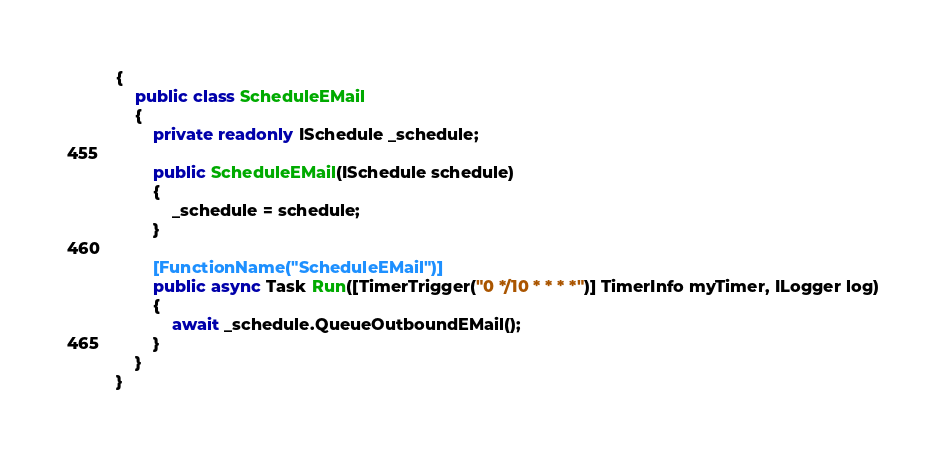<code> <loc_0><loc_0><loc_500><loc_500><_C#_>{
    public class ScheduleEMail
    {
        private readonly ISchedule _schedule;

        public ScheduleEMail(ISchedule schedule)
        {
            _schedule = schedule;
        }

        [FunctionName("ScheduleEMail")]
        public async Task Run([TimerTrigger("0 */10 * * * *")] TimerInfo myTimer, ILogger log)
        {
            await _schedule.QueueOutboundEMail();
        }
    }
}
</code> 